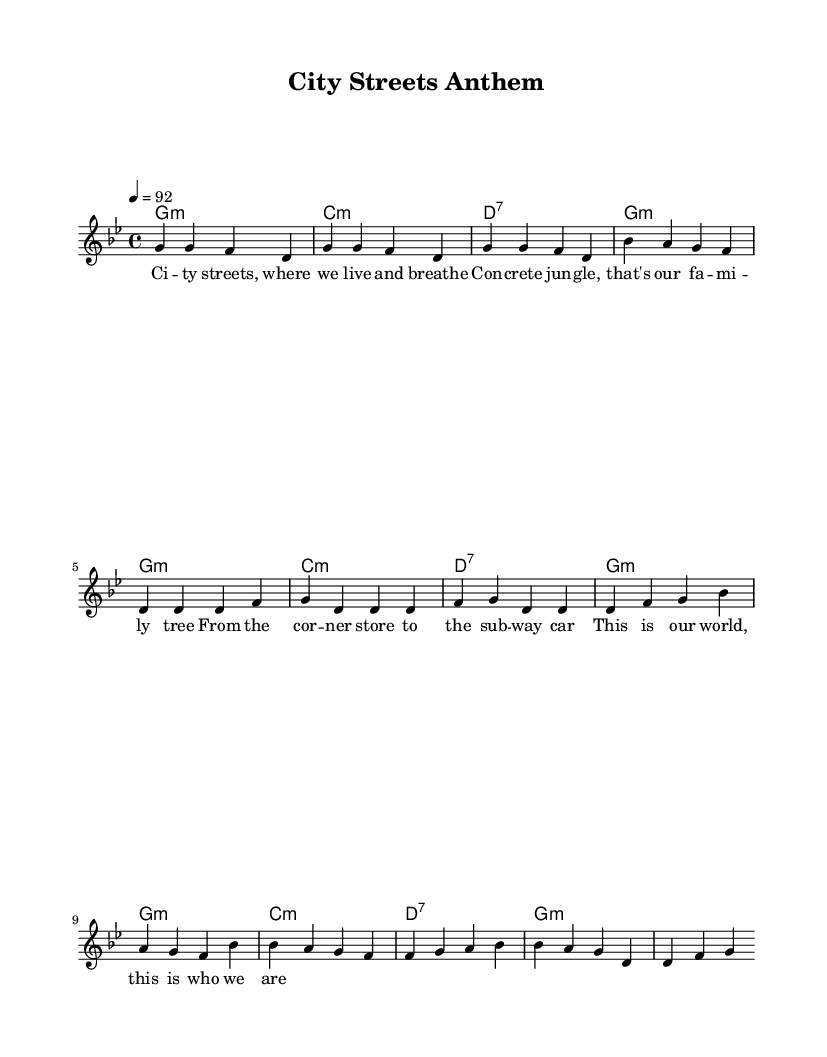What is the key signature of this music? The key signature is indicated by the symbol at the beginning of the staff. Since there is a B flat and no other accidentals, it is G minor which has two flats (B flat and E flat).
Answer: G minor What is the time signature of this music? The time signature is displayed near the beginning of the piece. It reads 4/4, which means there are four beats in each measure and the quarter note gets one beat.
Answer: 4/4 What is the tempo marking for this piece? The tempo is specified at the start with "4 = 92," indicating that the piece should be played at a speed of 92 beats per minute, where one beat corresponds to the quarter note.
Answer: 92 How many measures are in the verse section? The verse section comprises four measures as indicated in the melody line which follows the pattern in the music. Counting the measures, there are precisely four.
Answer: 4 What is the first word of the lyrics? The lyrics start just below the melody line, where the first note's corresponding word is displayed. The first word in the lyrics is "City."
Answer: City How many chord changes occur in the chorus section? By analyzing the chord pattern during the chorus, we notice it includes four distinct changes listed in the chord mode section. Hence, there are four changes for the chorus.
Answer: 4 What is the primary theme expressed in the lyrics? The lyrics reflect relationships with urban life and community. Examining the lyrics, the overarching theme celebrates vibrancy, identity, and a sense of belonging in the city.
Answer: Urban culture 